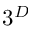<formula> <loc_0><loc_0><loc_500><loc_500>3 ^ { D }</formula> 